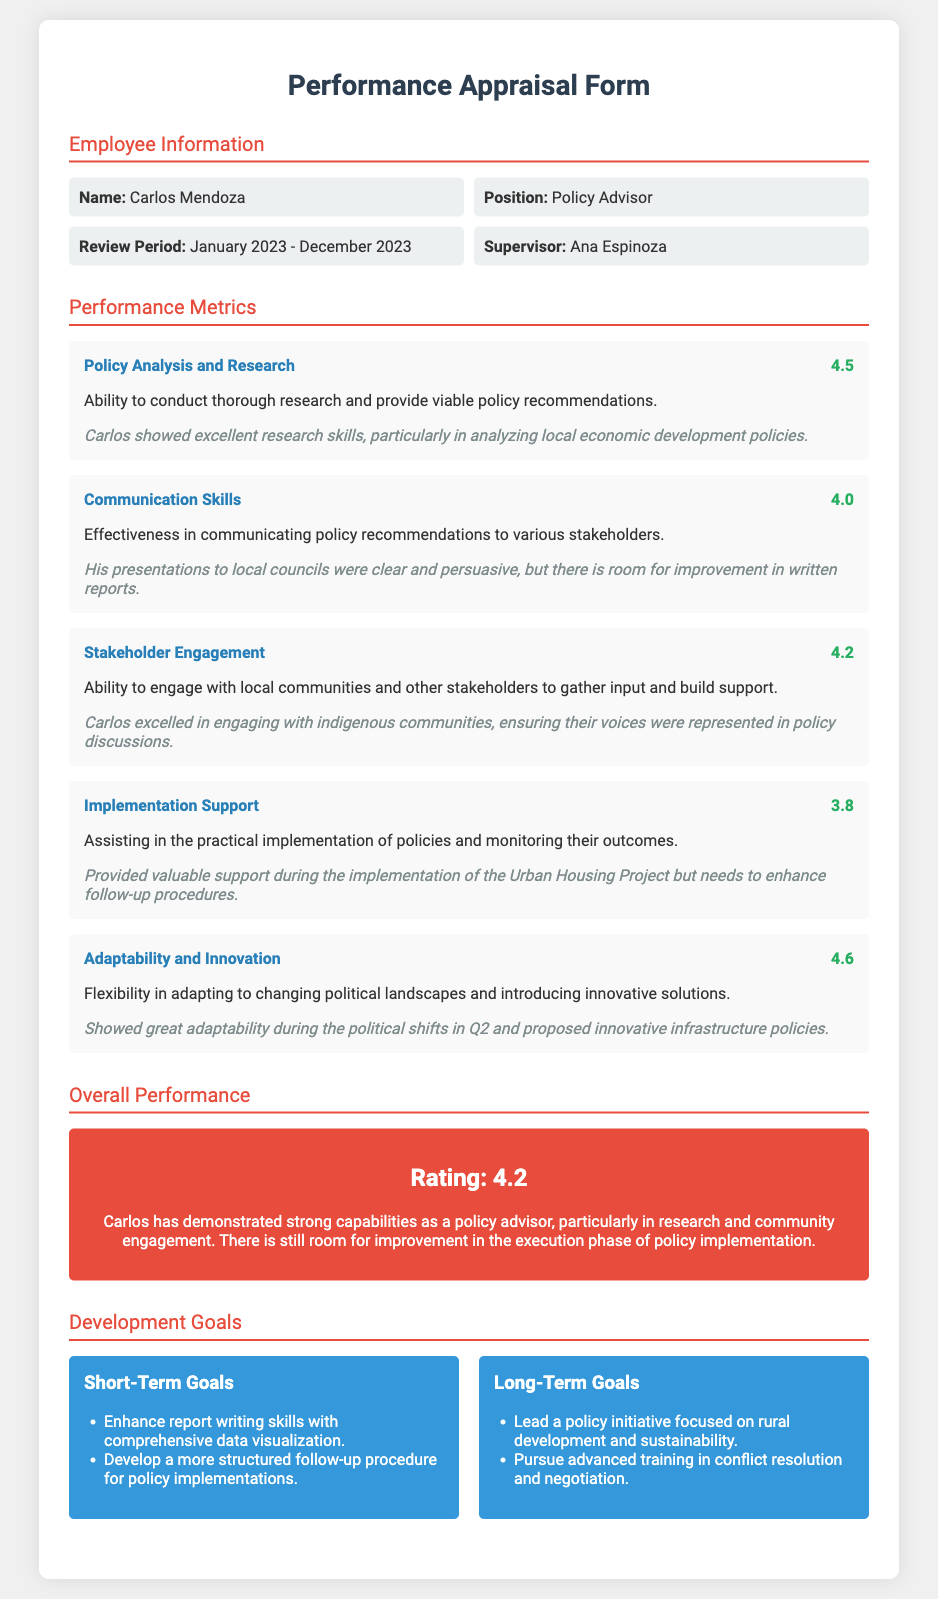What is the name of the employee? The name of the employee is noted under the Employee Information section.
Answer: Carlos Mendoza What is the position of Carlos Mendoza? The position is listed in the Employee Information section of the appraisal form.
Answer: Policy Advisor What was the review period for this appraisal? The review period is specified in the Employee Information section.
Answer: January 2023 - December 2023 Who is Carlos Mendoza's supervisor? The supervisor's name is provided in the Employee Information section.
Answer: Ana Espinoza What score did Carlos receive for Policy Analysis and Research? This score is presented in the Performance Metrics section.
Answer: 4.5 What is the overall performance rating for Carlos? The overall performance rating can be found in the Overall Performance section.
Answer: 4.2 Which area did Carlos excel in particularly? The appraisal mentions specific strengths in various areas under Performance Metrics.
Answer: Stakeholder Engagement What is one of the short-term goals listed for Carlos? Short-term goals can be found in the Development Goals section of the document.
Answer: Enhance report writing skills with comprehensive data visualization What long-term goal is mentioned for Carlos? Long-term goals are specified in the Development Goals section of the appraisal form.
Answer: Lead a policy initiative focused on rural development and sustainability What was a noted area for improvement in Carlos's performance? Areas for improvement are discussed in the Overall Performance section.
Answer: Execution phase of policy implementation 